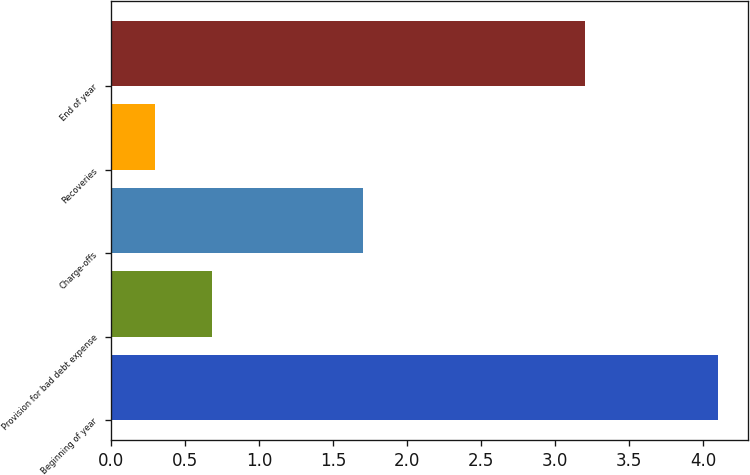Convert chart. <chart><loc_0><loc_0><loc_500><loc_500><bar_chart><fcel>Beginning of year<fcel>Provision for bad debt expense<fcel>Charge-offs<fcel>Recoveries<fcel>End of year<nl><fcel>4.1<fcel>0.68<fcel>1.7<fcel>0.3<fcel>3.2<nl></chart> 